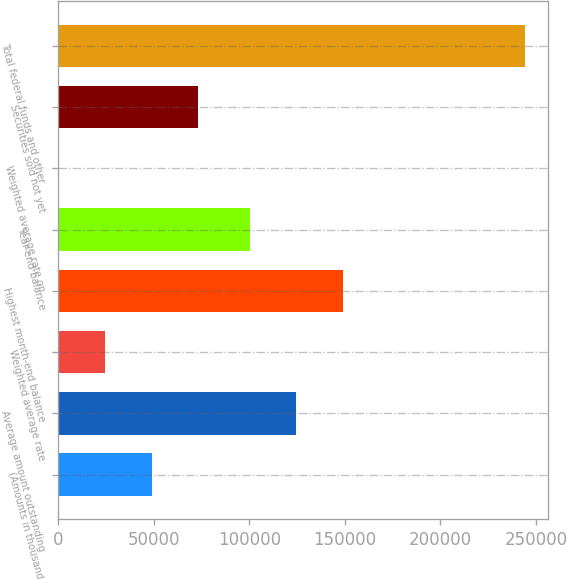<chart> <loc_0><loc_0><loc_500><loc_500><bar_chart><fcel>(Amounts in thousands)<fcel>Average amount outstanding<fcel>Weighted average rate<fcel>Highest month-end balance<fcel>Year-end balance<fcel>Weighted average rate on<fcel>Securities sold not yet<fcel>Total federal funds and other<nl><fcel>48844.7<fcel>124615<fcel>24422.4<fcel>149038<fcel>100193<fcel>0.15<fcel>73267<fcel>244223<nl></chart> 